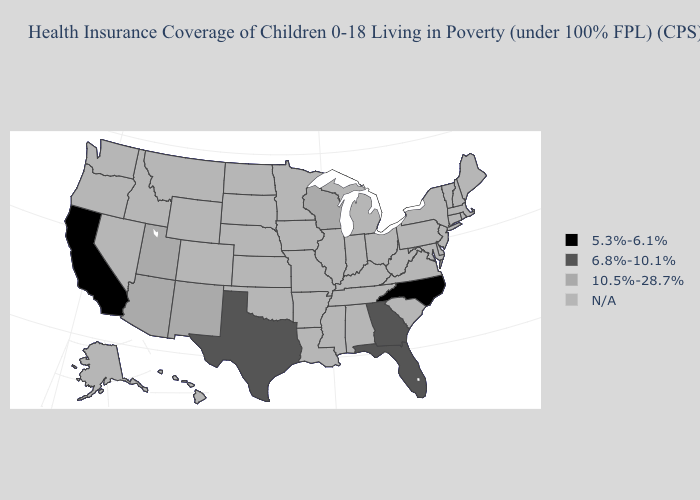Which states hav the highest value in the West?
Keep it brief. Arizona, New Mexico, Utah. Does the first symbol in the legend represent the smallest category?
Quick response, please. Yes. What is the value of Georgia?
Keep it brief. 6.8%-10.1%. What is the value of New Jersey?
Be succinct. N/A. Does North Carolina have the lowest value in the USA?
Answer briefly. Yes. Which states have the highest value in the USA?
Short answer required. Arizona, New Mexico, Utah, Wisconsin. Among the states that border Virginia , which have the highest value?
Quick response, please. North Carolina. What is the value of New Mexico?
Keep it brief. 10.5%-28.7%. What is the value of Illinois?
Write a very short answer. N/A. What is the value of Iowa?
Keep it brief. N/A. What is the lowest value in the USA?
Short answer required. 5.3%-6.1%. What is the value of Iowa?
Quick response, please. N/A. What is the lowest value in states that border Oregon?
Be succinct. 5.3%-6.1%. 